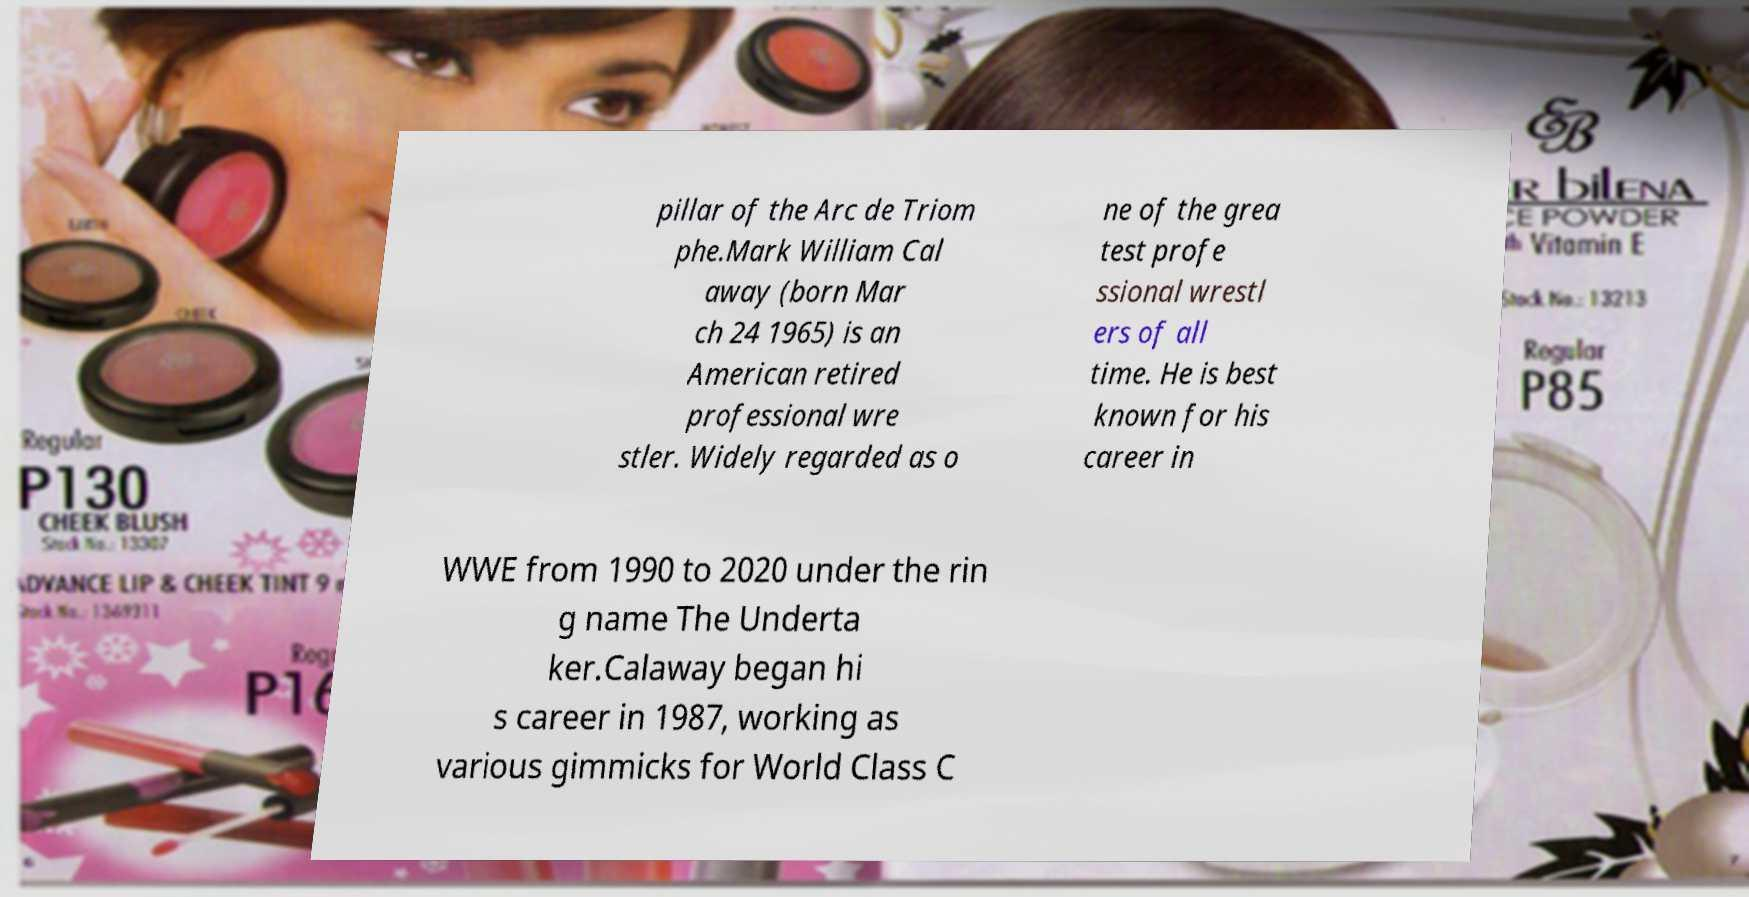Can you accurately transcribe the text from the provided image for me? pillar of the Arc de Triom phe.Mark William Cal away (born Mar ch 24 1965) is an American retired professional wre stler. Widely regarded as o ne of the grea test profe ssional wrestl ers of all time. He is best known for his career in WWE from 1990 to 2020 under the rin g name The Underta ker.Calaway began hi s career in 1987, working as various gimmicks for World Class C 